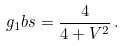Convert formula to latex. <formula><loc_0><loc_0><loc_500><loc_500>g _ { 1 } b s = \frac { 4 } { 4 + V ^ { 2 } } \, .</formula> 